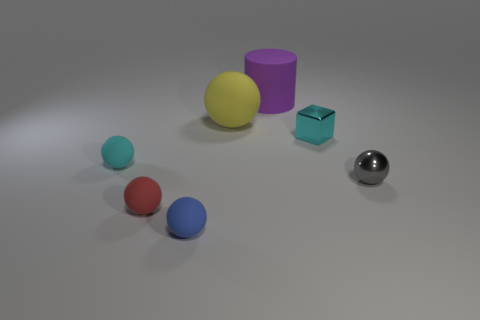What is the shape of the tiny cyan object that is to the left of the big matte thing behind the yellow thing?
Give a very brief answer. Sphere. There is a yellow rubber sphere; is its size the same as the cyan object that is to the left of the blue object?
Provide a short and direct response. No. How big is the cube that is left of the tiny sphere on the right side of the thing that is in front of the red rubber sphere?
Your answer should be very brief. Small. What number of objects are tiny metallic objects on the left side of the tiny gray sphere or blue things?
Your answer should be very brief. 2. There is a small cyan thing that is right of the big sphere; what number of rubber things are to the left of it?
Your answer should be compact. 5. Is the number of cyan metallic cubes that are in front of the cyan metallic object greater than the number of tiny red spheres?
Provide a succinct answer. No. What size is the rubber thing that is both behind the cyan sphere and in front of the cylinder?
Your answer should be compact. Large. What shape is the tiny object that is to the left of the purple object and to the right of the red rubber sphere?
Your response must be concise. Sphere. Are there any large cylinders that are in front of the cyan object on the right side of the purple cylinder that is right of the cyan ball?
Offer a very short reply. No. What number of things are either objects left of the small blue sphere or small objects right of the blue rubber sphere?
Provide a succinct answer. 4. 